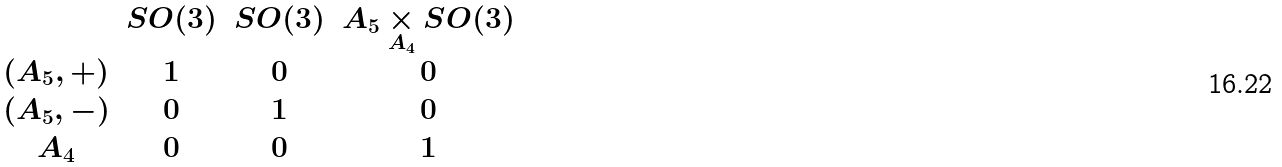<formula> <loc_0><loc_0><loc_500><loc_500>\begin{matrix} & { S O ( 3 ) } & { S O ( 3 ) } & { A _ { 5 } \underset { A _ { 4 } } \times S O ( 3 ) } \\ { ( A _ { 5 } , + ) } & 1 & 0 & 0 \\ { ( A _ { 5 } , - ) } & 0 & 1 & 0 \\ { A _ { 4 } } & 0 & 0 & 1 \end{matrix}</formula> 